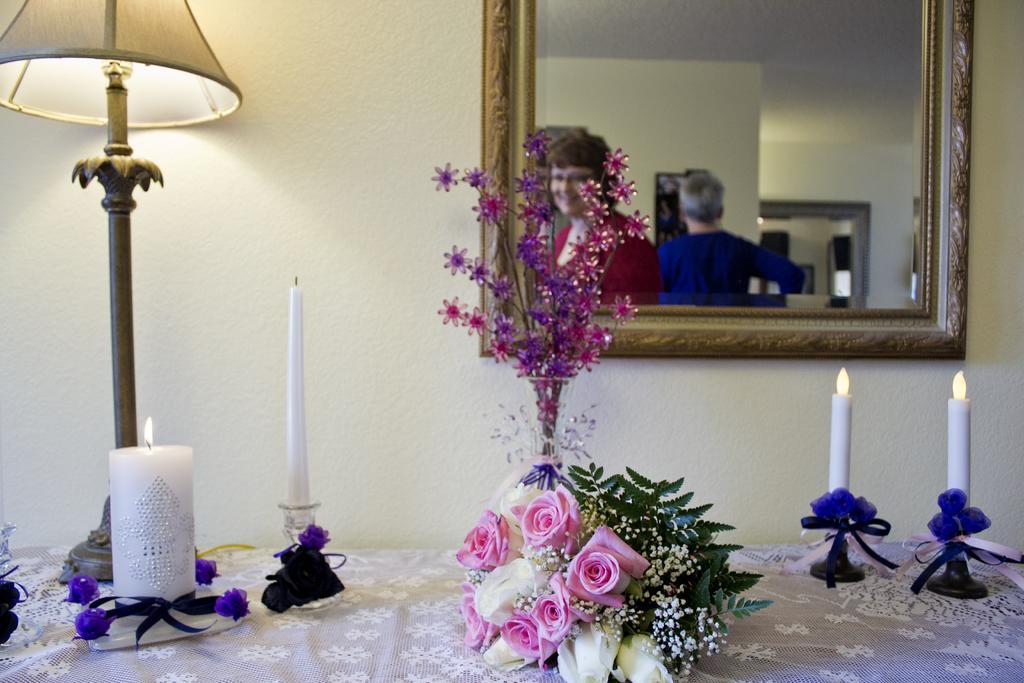Can you describe this image briefly? In this image I can see a table on which we can see candles, flower bouquet also there is a mirror on the wall with reflection of people on it. 